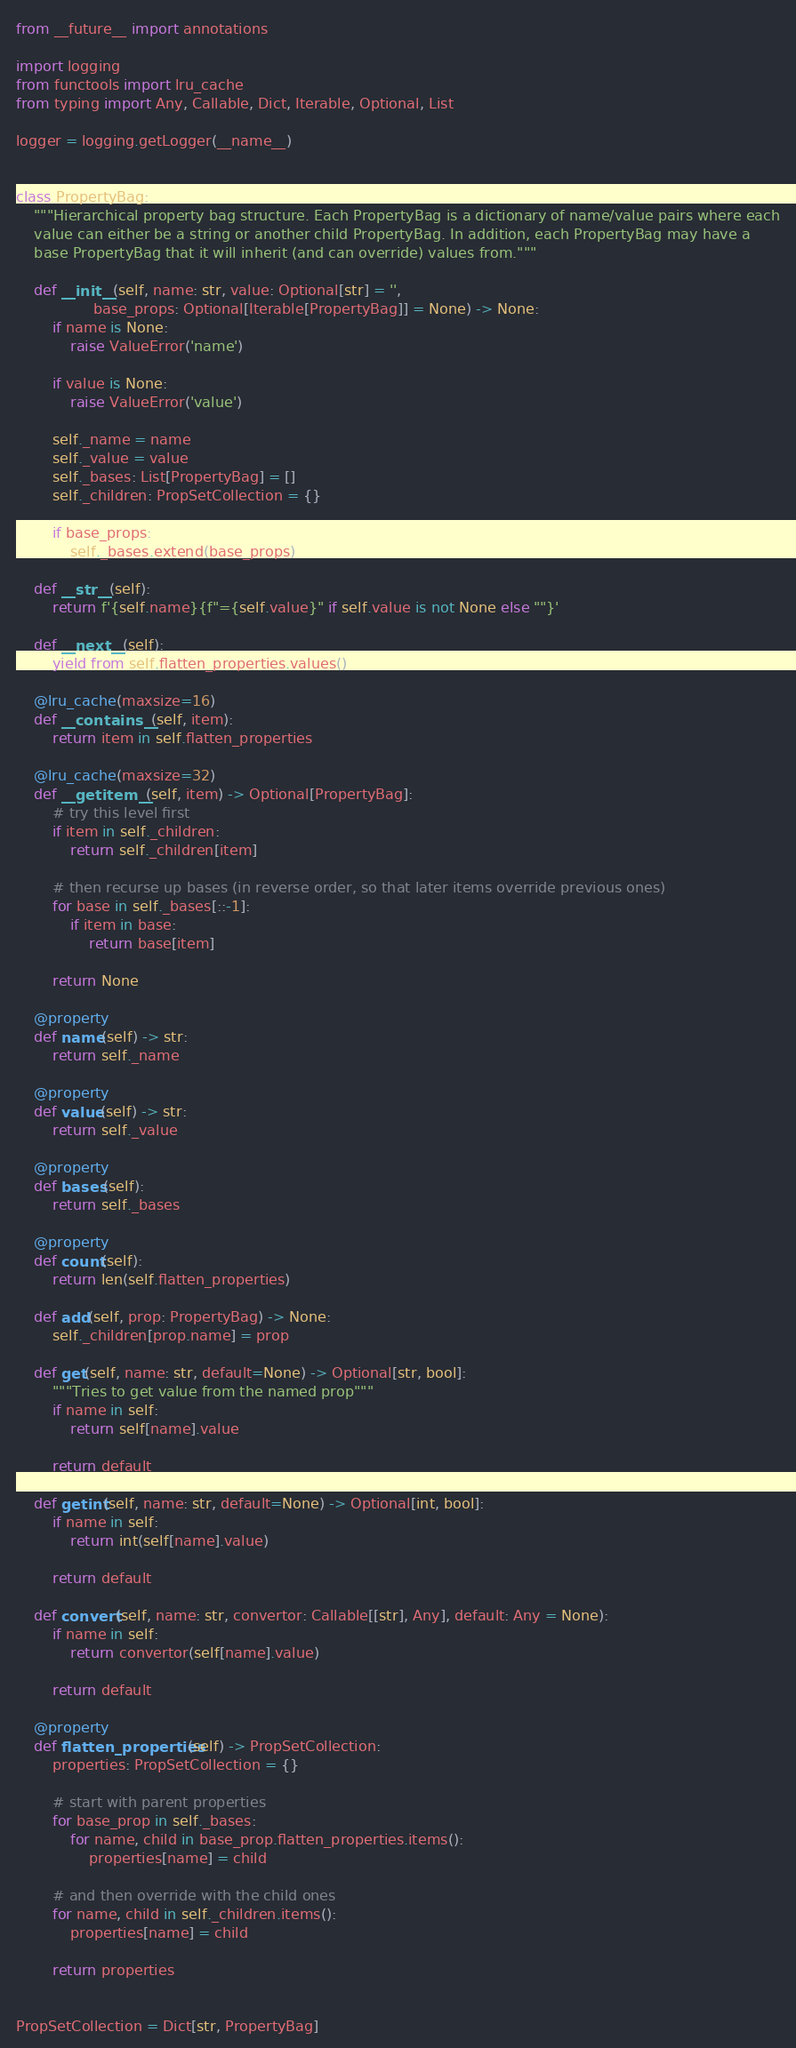<code> <loc_0><loc_0><loc_500><loc_500><_Python_>from __future__ import annotations

import logging
from functools import lru_cache
from typing import Any, Callable, Dict, Iterable, Optional, List

logger = logging.getLogger(__name__)


class PropertyBag:
    """Hierarchical property bag structure. Each PropertyBag is a dictionary of name/value pairs where each
    value can either be a string or another child PropertyBag. In addition, each PropertyBag may have a
    base PropertyBag that it will inherit (and can override) values from."""

    def __init__(self, name: str, value: Optional[str] = '',
                 base_props: Optional[Iterable[PropertyBag]] = None) -> None:
        if name is None:
            raise ValueError('name')

        if value is None:
            raise ValueError('value')

        self._name = name
        self._value = value
        self._bases: List[PropertyBag] = []
        self._children: PropSetCollection = {}

        if base_props:
            self._bases.extend(base_props)

    def __str__(self):
        return f'{self.name}{f"={self.value}" if self.value is not None else ""}'

    def __next__(self):
        yield from self.flatten_properties.values()

    @lru_cache(maxsize=16)
    def __contains__(self, item):
        return item in self.flatten_properties

    @lru_cache(maxsize=32)
    def __getitem__(self, item) -> Optional[PropertyBag]:
        # try this level first
        if item in self._children:
            return self._children[item]

        # then recurse up bases (in reverse order, so that later items override previous ones)
        for base in self._bases[::-1]:
            if item in base:
                return base[item]

        return None

    @property
    def name(self) -> str:
        return self._name

    @property
    def value(self) -> str:
        return self._value

    @property
    def bases(self):
        return self._bases

    @property
    def count(self):
        return len(self.flatten_properties)

    def add(self, prop: PropertyBag) -> None:
        self._children[prop.name] = prop

    def get(self, name: str, default=None) -> Optional[str, bool]:
        """Tries to get value from the named prop"""
        if name in self:
            return self[name].value

        return default

    def getint(self, name: str, default=None) -> Optional[int, bool]:
        if name in self:
            return int(self[name].value)

        return default

    def convert(self, name: str, convertor: Callable[[str], Any], default: Any = None):
        if name in self:
            return convertor(self[name].value)

        return default

    @property
    def flatten_properties(self) -> PropSetCollection:
        properties: PropSetCollection = {}

        # start with parent properties
        for base_prop in self._bases:
            for name, child in base_prop.flatten_properties.items():
                properties[name] = child

        # and then override with the child ones
        for name, child in self._children.items():
            properties[name] = child

        return properties


PropSetCollection = Dict[str, PropertyBag]
</code> 